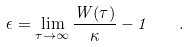<formula> <loc_0><loc_0><loc_500><loc_500>\epsilon = \lim _ { \tau \to \infty } \frac { W ( \tau ) } { \kappa } - 1 \quad .</formula> 